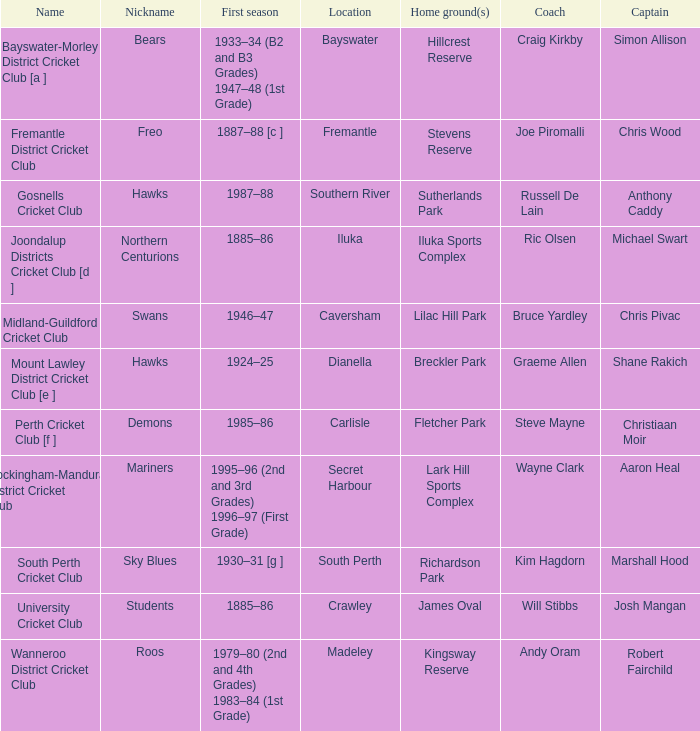Could you parse the entire table as a dict? {'header': ['Name', 'Nickname', 'First season', 'Location', 'Home ground(s)', 'Coach', 'Captain'], 'rows': [['Bayswater-Morley District Cricket Club [a ]', 'Bears', '1933–34 (B2 and B3 Grades) 1947–48 (1st Grade)', 'Bayswater', 'Hillcrest Reserve', 'Craig Kirkby', 'Simon Allison'], ['Fremantle District Cricket Club', 'Freo', '1887–88 [c ]', 'Fremantle', 'Stevens Reserve', 'Joe Piromalli', 'Chris Wood'], ['Gosnells Cricket Club', 'Hawks', '1987–88', 'Southern River', 'Sutherlands Park', 'Russell De Lain', 'Anthony Caddy'], ['Joondalup Districts Cricket Club [d ]', 'Northern Centurions', '1885–86', 'Iluka', 'Iluka Sports Complex', 'Ric Olsen', 'Michael Swart'], ['Midland-Guildford Cricket Club', 'Swans', '1946–47', 'Caversham', 'Lilac Hill Park', 'Bruce Yardley', 'Chris Pivac'], ['Mount Lawley District Cricket Club [e ]', 'Hawks', '1924–25', 'Dianella', 'Breckler Park', 'Graeme Allen', 'Shane Rakich'], ['Perth Cricket Club [f ]', 'Demons', '1985–86', 'Carlisle', 'Fletcher Park', 'Steve Mayne', 'Christiaan Moir'], ['Rockingham-Mandurah District Cricket Club', 'Mariners', '1995–96 (2nd and 3rd Grades) 1996–97 (First Grade)', 'Secret Harbour', 'Lark Hill Sports Complex', 'Wayne Clark', 'Aaron Heal'], ['South Perth Cricket Club', 'Sky Blues', '1930–31 [g ]', 'South Perth', 'Richardson Park', 'Kim Hagdorn', 'Marshall Hood'], ['University Cricket Club', 'Students', '1885–86', 'Crawley', 'James Oval', 'Will Stibbs', 'Josh Mangan'], ['Wanneroo District Cricket Club', 'Roos', '1979–80 (2nd and 4th Grades) 1983–84 (1st Grade)', 'Madeley', 'Kingsway Reserve', 'Andy Oram', 'Robert Fairchild']]} What is the location for the club with the nickname the bears? Bayswater. 